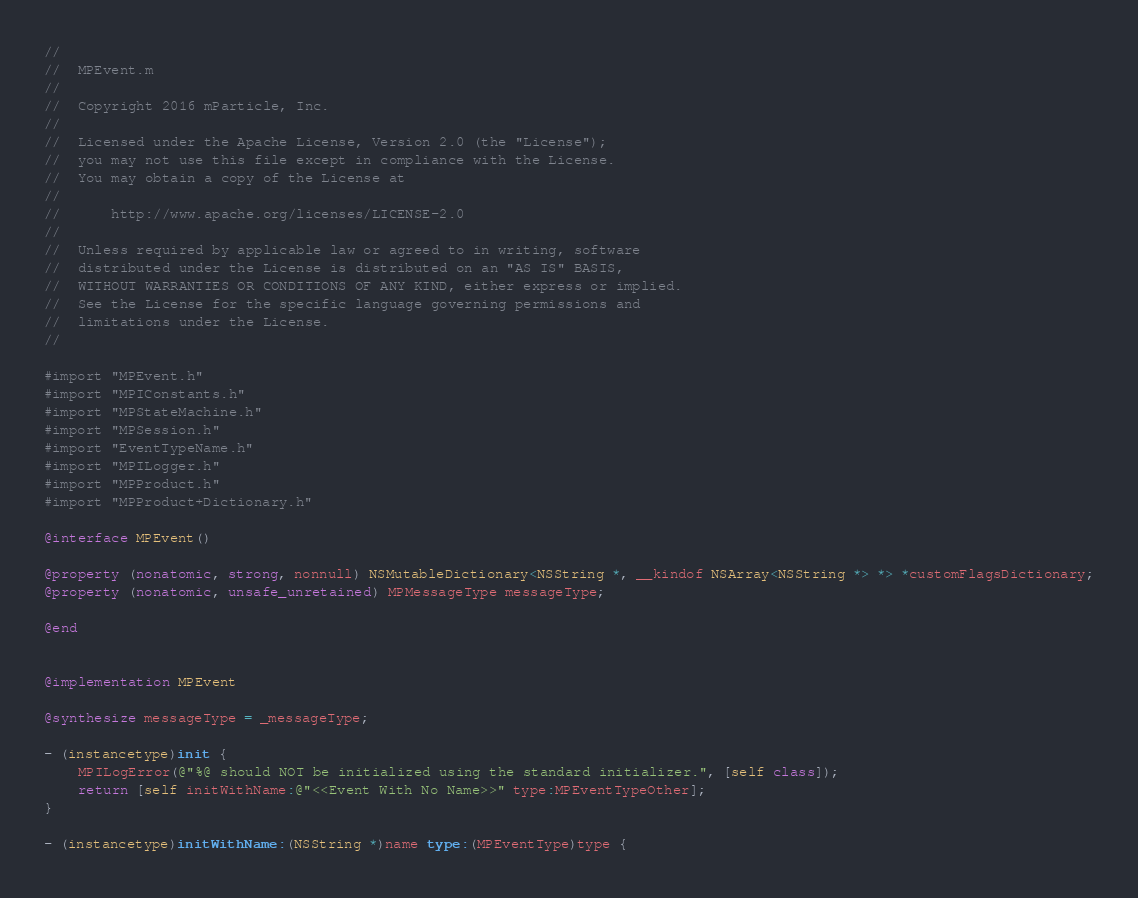<code> <loc_0><loc_0><loc_500><loc_500><_ObjectiveC_>//
//  MPEvent.m
//
//  Copyright 2016 mParticle, Inc.
//
//  Licensed under the Apache License, Version 2.0 (the "License");
//  you may not use this file except in compliance with the License.
//  You may obtain a copy of the License at
//
//      http://www.apache.org/licenses/LICENSE-2.0
//
//  Unless required by applicable law or agreed to in writing, software
//  distributed under the License is distributed on an "AS IS" BASIS,
//  WITHOUT WARRANTIES OR CONDITIONS OF ANY KIND, either express or implied.
//  See the License for the specific language governing permissions and
//  limitations under the License.
//

#import "MPEvent.h"
#import "MPIConstants.h"
#import "MPStateMachine.h"
#import "MPSession.h"
#import "EventTypeName.h"
#import "MPILogger.h"
#import "MPProduct.h"
#import "MPProduct+Dictionary.h"

@interface MPEvent()

@property (nonatomic, strong, nonnull) NSMutableDictionary<NSString *, __kindof NSArray<NSString *> *> *customFlagsDictionary;
@property (nonatomic, unsafe_unretained) MPMessageType messageType;

@end


@implementation MPEvent

@synthesize messageType = _messageType;

- (instancetype)init {
    MPILogError(@"%@ should NOT be initialized using the standard initializer.", [self class]);
    return [self initWithName:@"<<Event With No Name>>" type:MPEventTypeOther];
}

- (instancetype)initWithName:(NSString *)name type:(MPEventType)type {</code> 